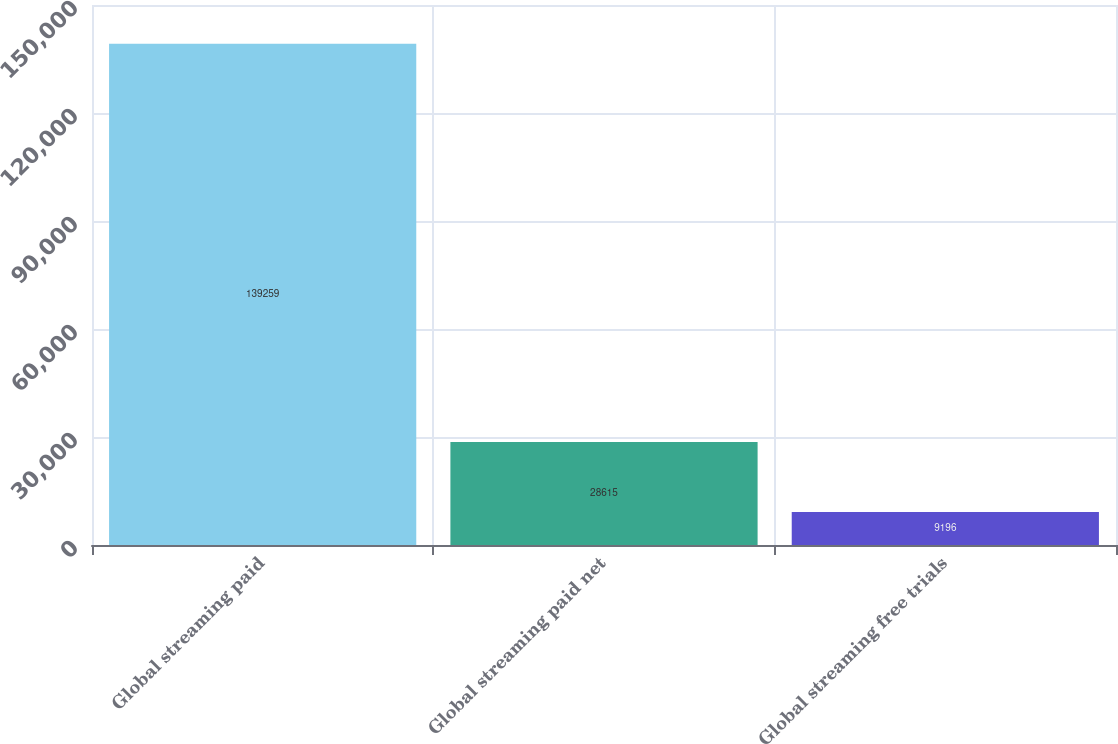<chart> <loc_0><loc_0><loc_500><loc_500><bar_chart><fcel>Global streaming paid<fcel>Global streaming paid net<fcel>Global streaming free trials<nl><fcel>139259<fcel>28615<fcel>9196<nl></chart> 